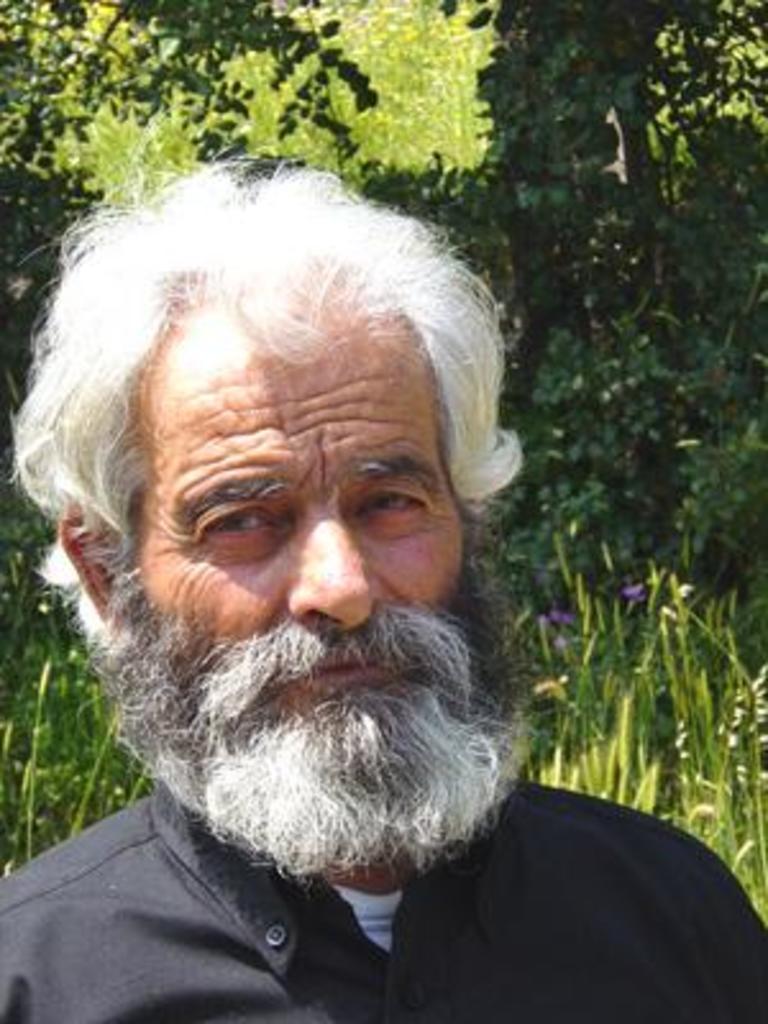Describe this image in one or two sentences. In this image I can see an old man is looking this side. At the back side there are trees. 